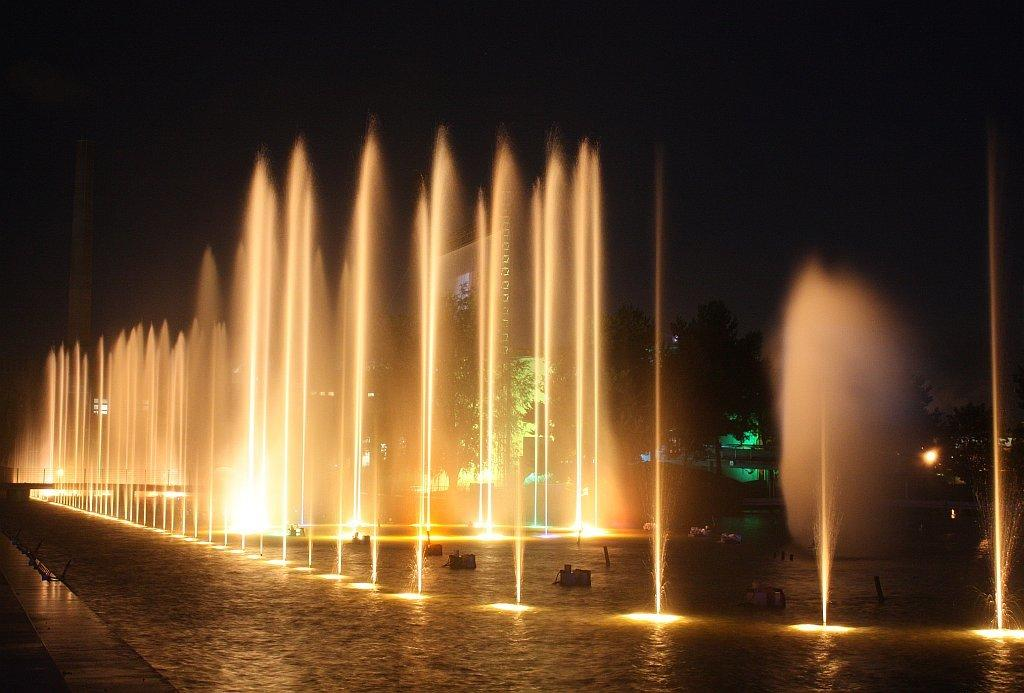What is the main feature in the image? There is a water fountain in the image. What else can be seen in the image besides the water fountain? There are lights and trees visible in the image. What is the condition of the sky in the image? The sky is visible at the top of the image. What time of day is the image taken? The image is taken in night view. What type of discovery was made at the water fountain in the image? There is no mention of any discovery in the image; it simply features a water fountain, lights, trees, and a night sky. What is the friction between the water and the fountain in the image? The image does not provide information about the friction between the water and the fountain, as it is a still image and not a video or interactive representation. 